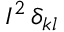<formula> <loc_0><loc_0><loc_500><loc_500>I ^ { 2 } \, \delta _ { k l }</formula> 